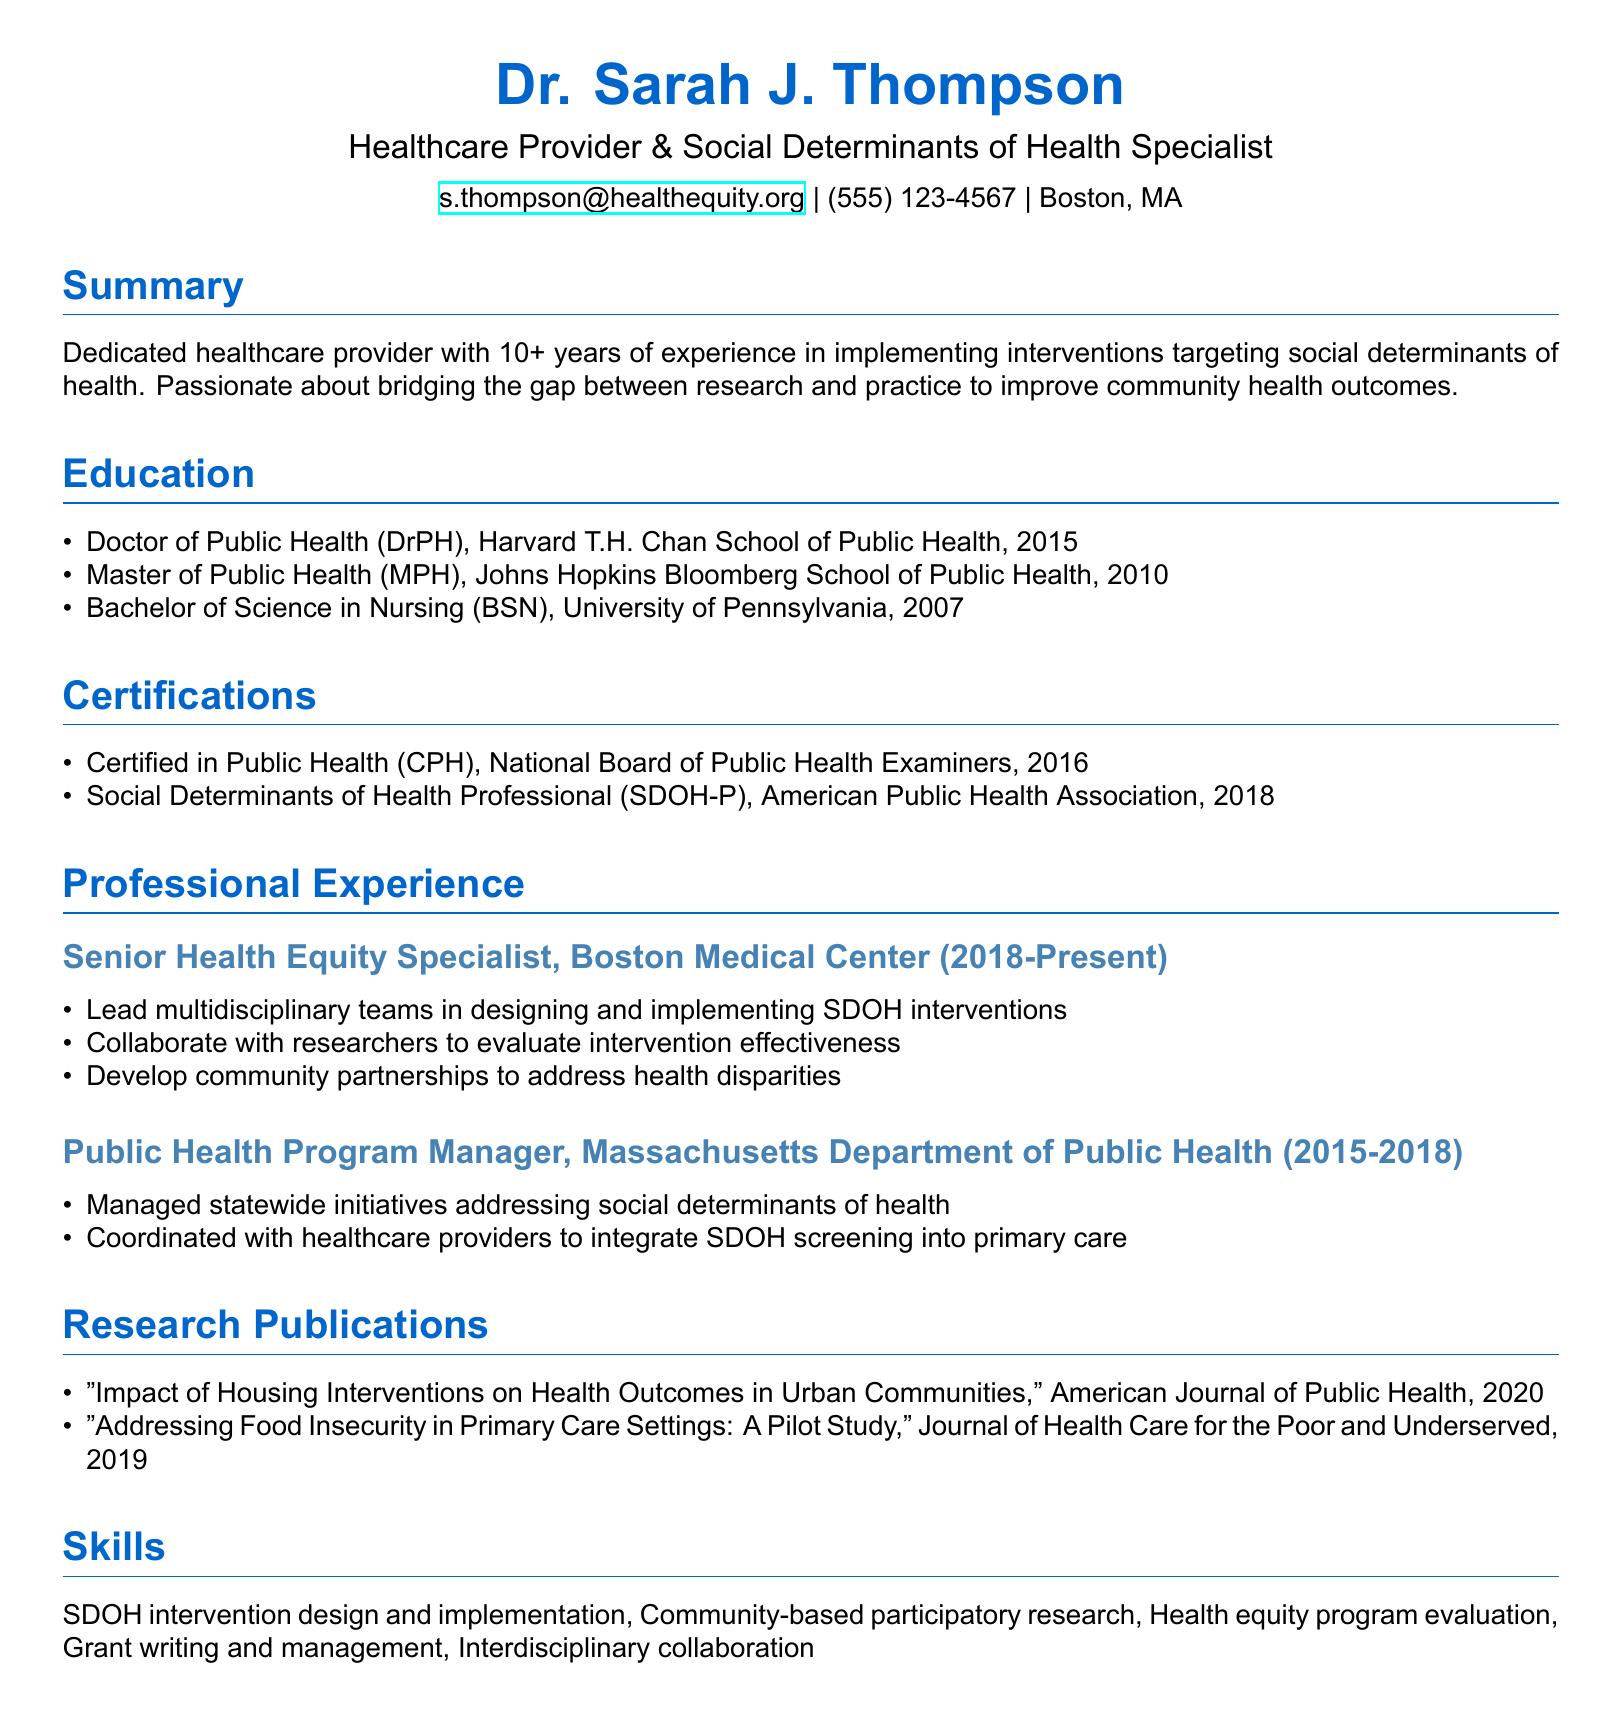What is the name of the specialist? The name listed in the document is the individual who specializes in social determinants of health.
Answer: Dr. Sarah J. Thompson What is the highest degree obtained by Dr. Thompson? The document specifies the degrees earned, and the highest degree is the doctoral level.
Answer: Doctor of Public Health (DrPH) Which organization issued the Certified in Public Health certification? The document identifies the certifying body for the certification in public health.
Answer: National Board of Public Health Examiners What is one of the responsibilities of the Senior Health Equity Specialist? The document outlines key responsibilities in this role, one of which is to lead teams in a specific area.
Answer: Lead multidisciplinary teams in designing and implementing SDOH interventions In which year was the Social Determinants of Health Professional certification obtained? The document provides the year when the certification was acquired, following the certification details.
Answer: 2018 How many years of experience does Dr. Thompson have? The summary section mentions the total experience directly related to the field of social determinants of health.
Answer: 10+ What is one of the main focuses in Dr. Thompson's research publications? The titles of the research publications indicate essential health issues addressed by the author, one being housing.
Answer: Housing Interventions What type of research approach does Dr. Thompson emphasize? Skills listed in the document identify the research methodology that Dr. Thompson prioritizes in her work.
Answer: Community-based participatory research 